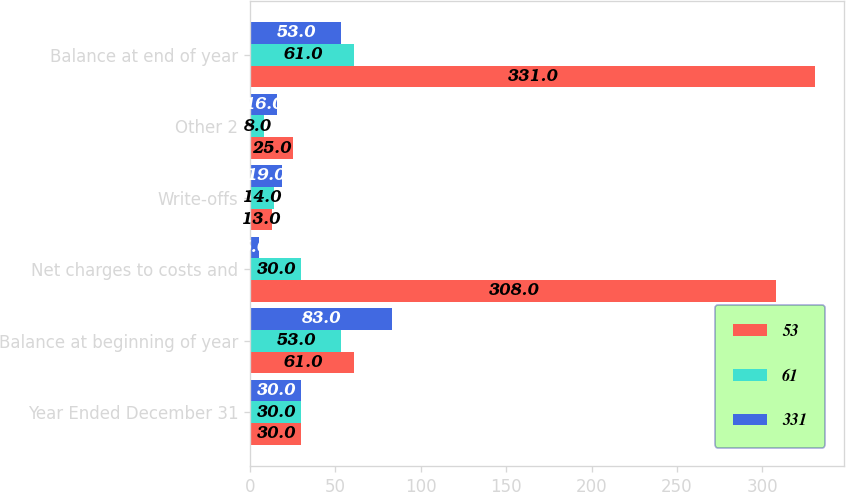Convert chart to OTSL. <chart><loc_0><loc_0><loc_500><loc_500><stacked_bar_chart><ecel><fcel>Year Ended December 31<fcel>Balance at beginning of year<fcel>Net charges to costs and<fcel>Write-offs<fcel>Other 2<fcel>Balance at end of year<nl><fcel>53<fcel>30<fcel>61<fcel>308<fcel>13<fcel>25<fcel>331<nl><fcel>61<fcel>30<fcel>53<fcel>30<fcel>14<fcel>8<fcel>61<nl><fcel>331<fcel>30<fcel>83<fcel>5<fcel>19<fcel>16<fcel>53<nl></chart> 